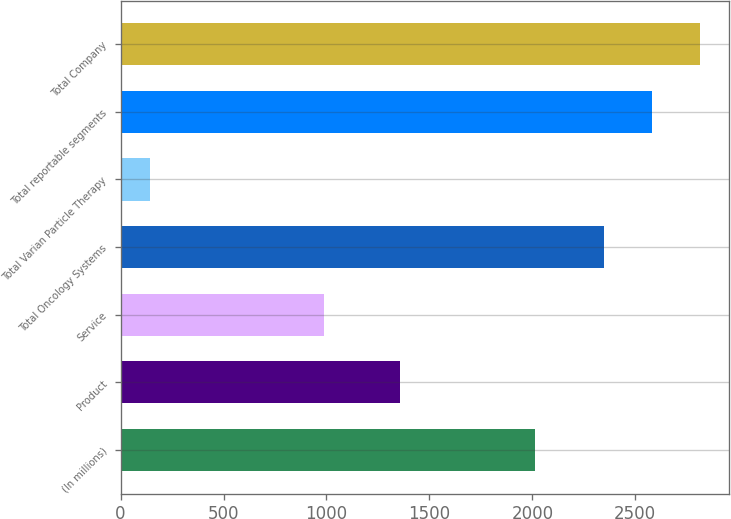Convert chart to OTSL. <chart><loc_0><loc_0><loc_500><loc_500><bar_chart><fcel>(In millions)<fcel>Product<fcel>Service<fcel>Total Oncology Systems<fcel>Total Varian Particle Therapy<fcel>Total reportable segments<fcel>Total Company<nl><fcel>2015<fcel>1359.2<fcel>987.6<fcel>2346.8<fcel>143.5<fcel>2581.52<fcel>2816.24<nl></chart> 